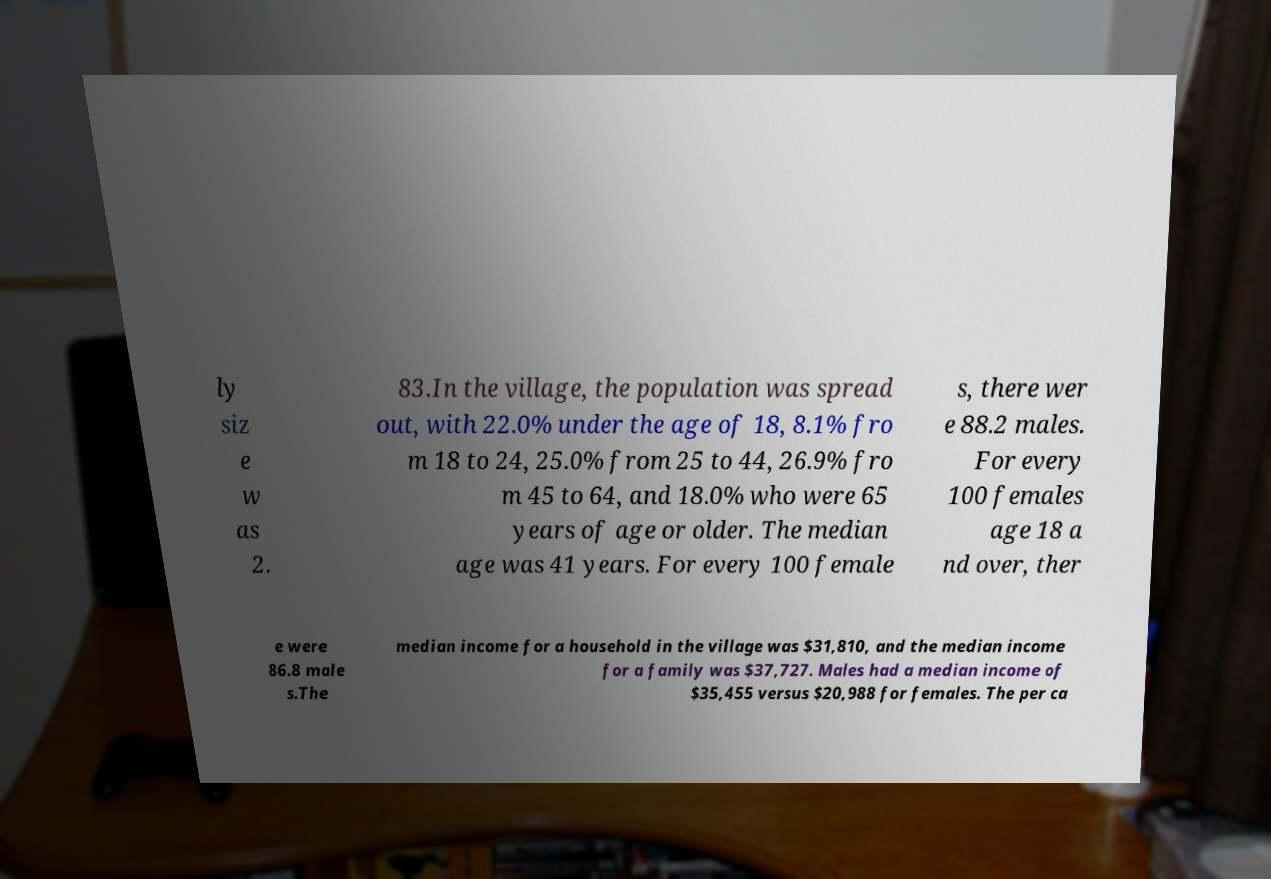I need the written content from this picture converted into text. Can you do that? ly siz e w as 2. 83.In the village, the population was spread out, with 22.0% under the age of 18, 8.1% fro m 18 to 24, 25.0% from 25 to 44, 26.9% fro m 45 to 64, and 18.0% who were 65 years of age or older. The median age was 41 years. For every 100 female s, there wer e 88.2 males. For every 100 females age 18 a nd over, ther e were 86.8 male s.The median income for a household in the village was $31,810, and the median income for a family was $37,727. Males had a median income of $35,455 versus $20,988 for females. The per ca 